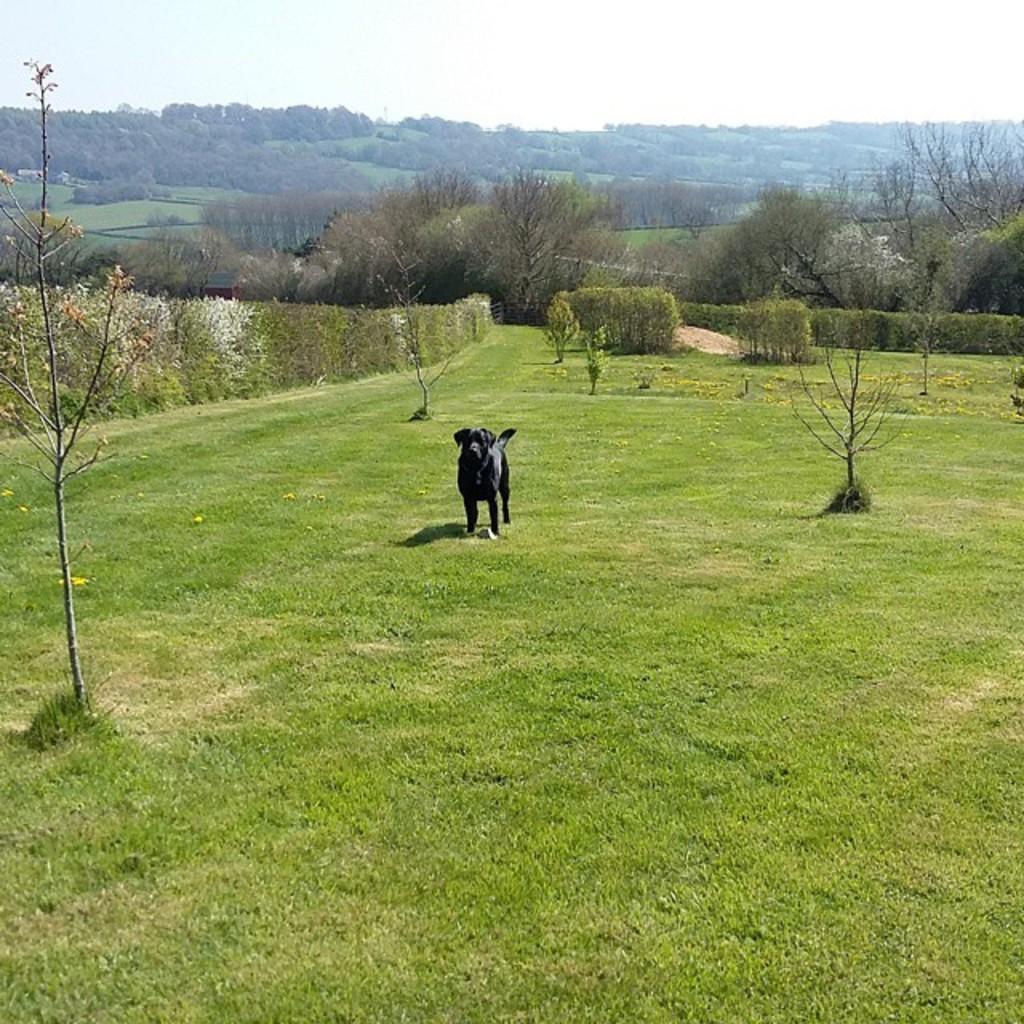How would you summarize this image in a sentence or two? In the middle of the image we can see a dog on the grass, in the background we can see few trees. 